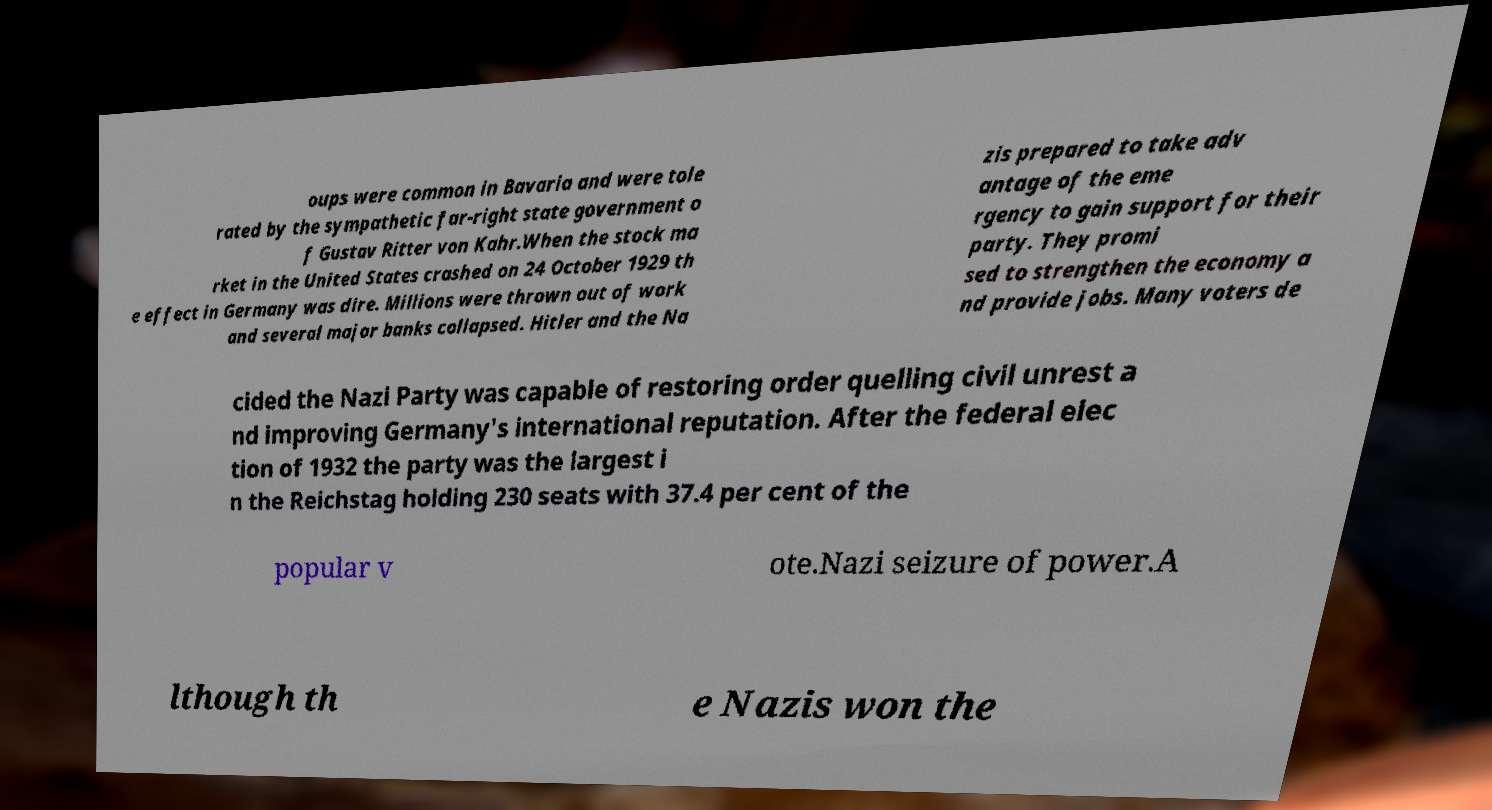Please read and relay the text visible in this image. What does it say? oups were common in Bavaria and were tole rated by the sympathetic far-right state government o f Gustav Ritter von Kahr.When the stock ma rket in the United States crashed on 24 October 1929 th e effect in Germany was dire. Millions were thrown out of work and several major banks collapsed. Hitler and the Na zis prepared to take adv antage of the eme rgency to gain support for their party. They promi sed to strengthen the economy a nd provide jobs. Many voters de cided the Nazi Party was capable of restoring order quelling civil unrest a nd improving Germany's international reputation. After the federal elec tion of 1932 the party was the largest i n the Reichstag holding 230 seats with 37.4 per cent of the popular v ote.Nazi seizure of power.A lthough th e Nazis won the 